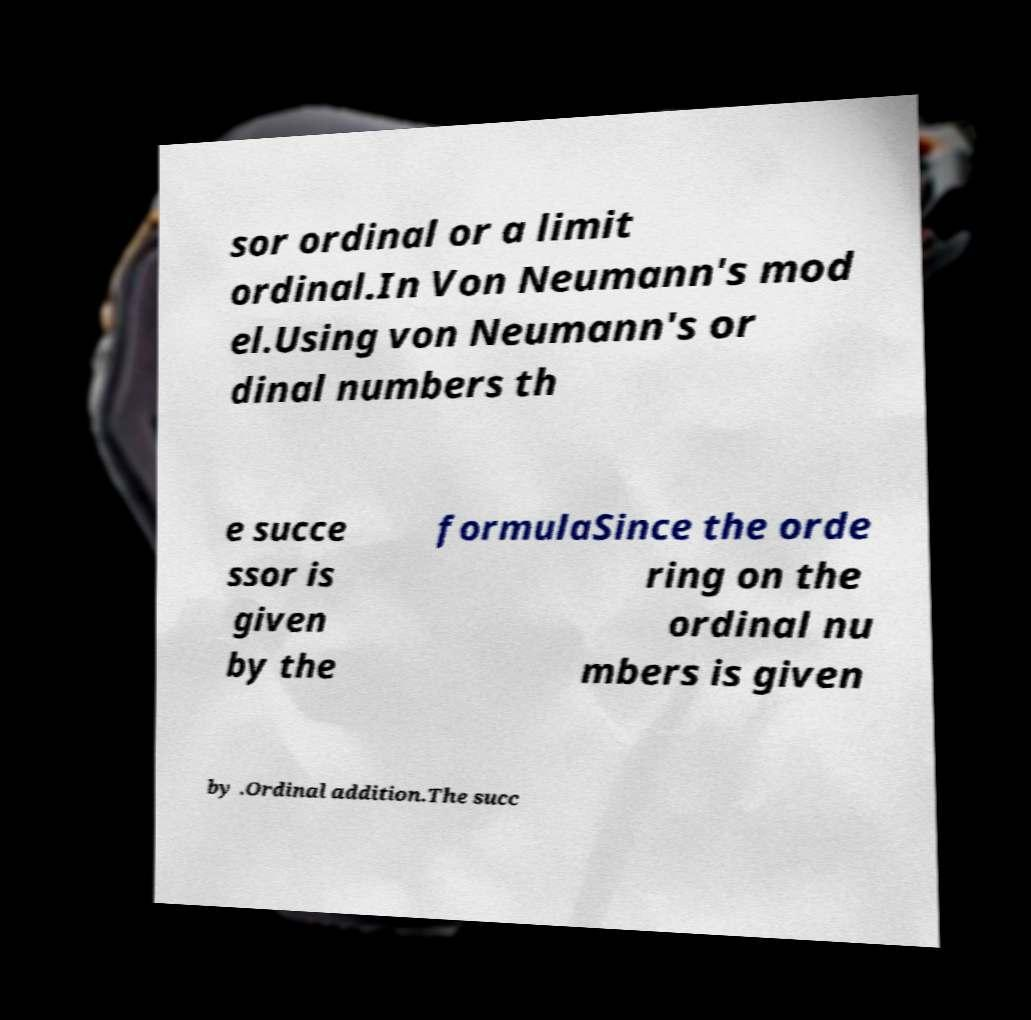I need the written content from this picture converted into text. Can you do that? sor ordinal or a limit ordinal.In Von Neumann's mod el.Using von Neumann's or dinal numbers th e succe ssor is given by the formulaSince the orde ring on the ordinal nu mbers is given by .Ordinal addition.The succ 